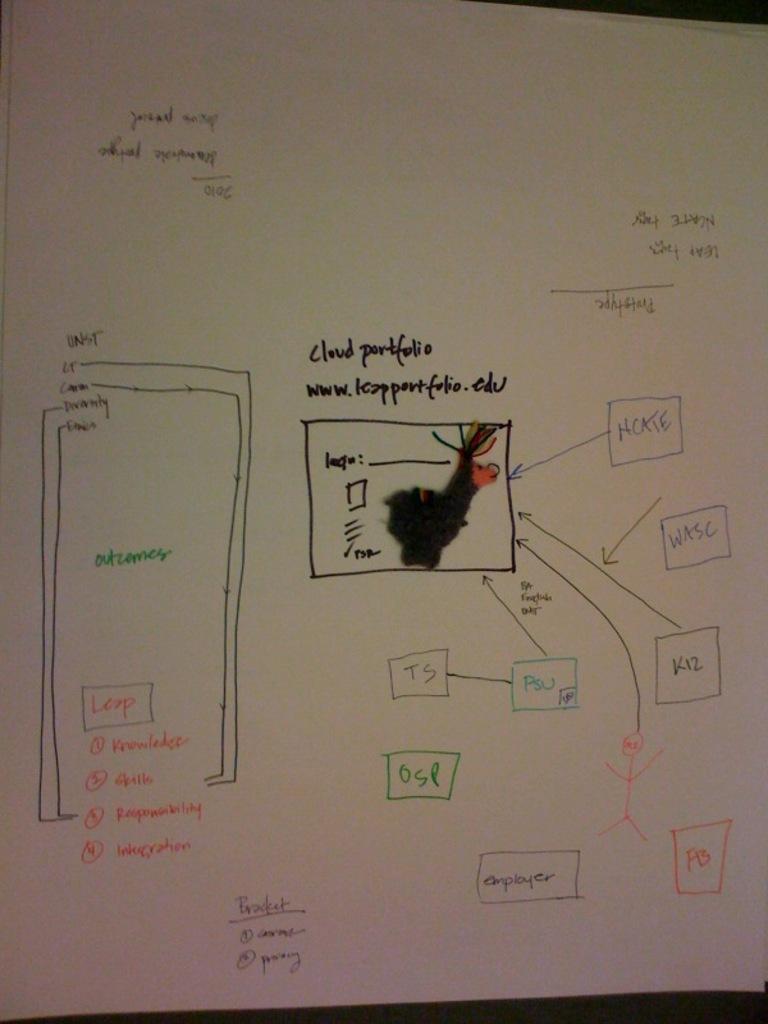Could you give a brief overview of what you see in this image? In this image we can see some written text on the paper. 